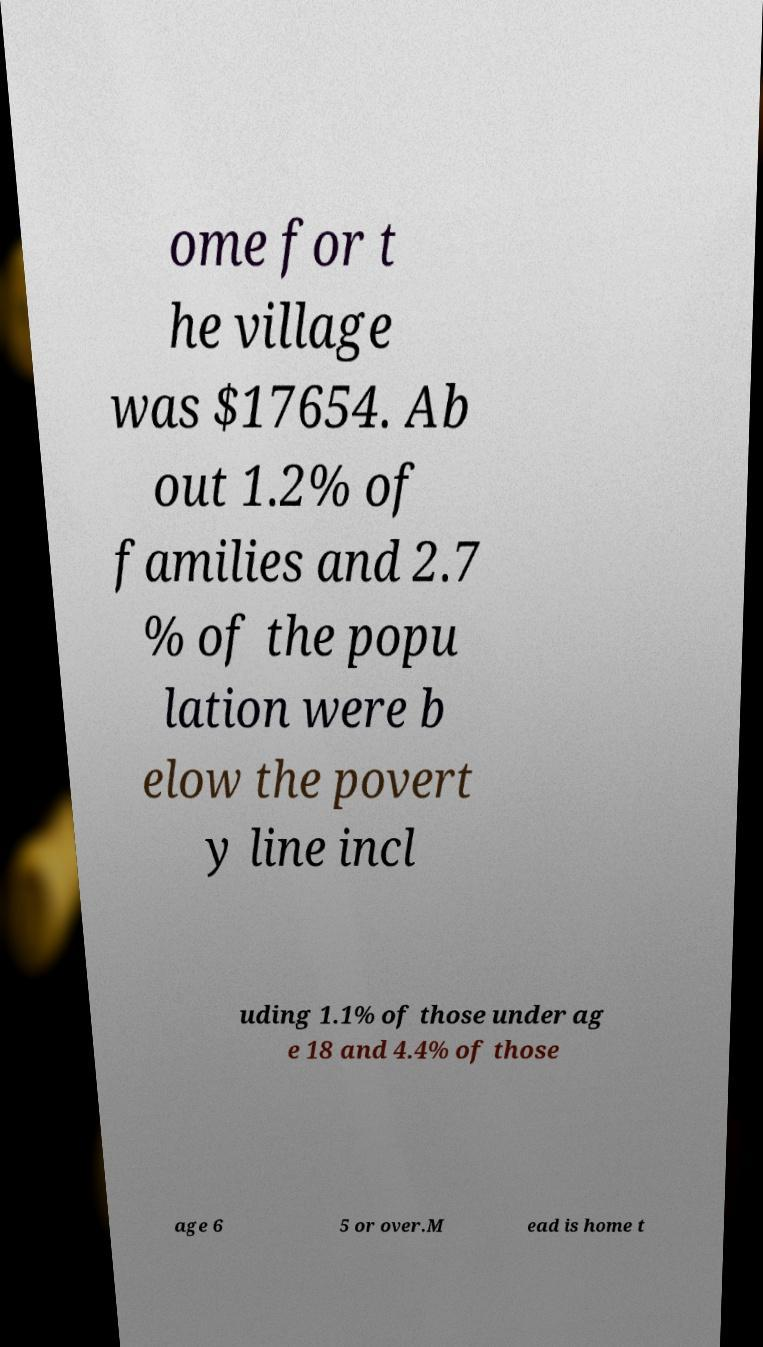Could you assist in decoding the text presented in this image and type it out clearly? ome for t he village was $17654. Ab out 1.2% of families and 2.7 % of the popu lation were b elow the povert y line incl uding 1.1% of those under ag e 18 and 4.4% of those age 6 5 or over.M ead is home t 